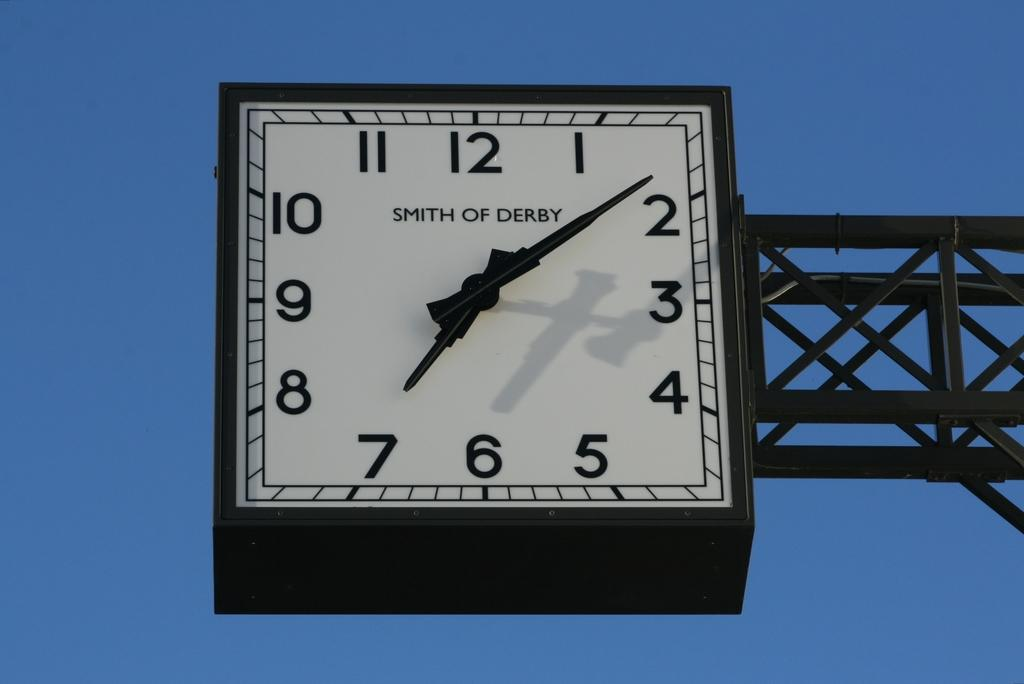<image>
Share a concise interpretation of the image provided. A square clock manufactured by Smith of Derby shows the time as 7:08. 